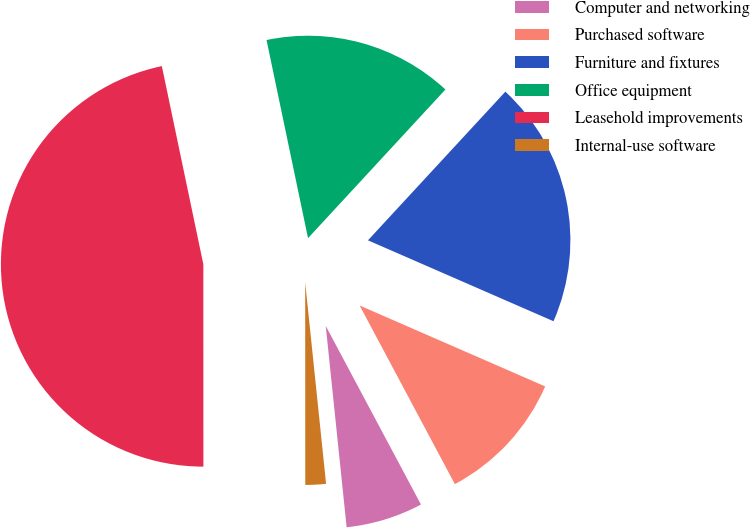<chart> <loc_0><loc_0><loc_500><loc_500><pie_chart><fcel>Computer and networking<fcel>Purchased software<fcel>Furniture and fixtures<fcel>Office equipment<fcel>Leasehold improvements<fcel>Internal-use software<nl><fcel>6.15%<fcel>10.66%<fcel>19.67%<fcel>15.16%<fcel>46.72%<fcel>1.64%<nl></chart> 